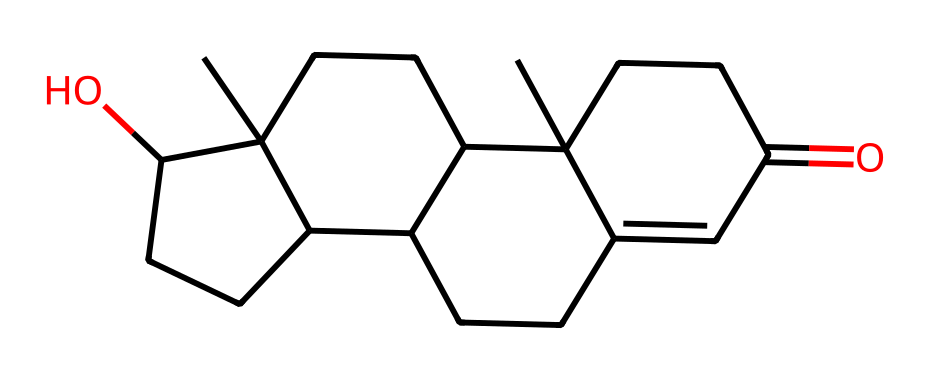What is the name of the hormone represented by this chemical structure? The SMILES representation corresponds to a molecule known for its role in hormone regulation and is specifically identified as testosterone.
Answer: testosterone How many carbon atoms are present in the structure? Analyzing the SMILES notation, each 'C' corresponds to a carbon atom, totaling up to 19 carbon atoms in the structure of testosterone.
Answer: 19 What is the functional group present in the structure? The structure includes an alcohol group (–OH) indicated by the 'O' connected to a carbon atom, which classifies it as a steroid with a hydroxyl functional group.
Answer: hydroxyl What type of molecule is testosterone classified as? Testosterone is classified as a steroid hormone due to its multi-ring structure and presence of functional groups typical of steroid compounds.
Answer: steroid How many rings are present in the molecular structure? The structure reveals four interconnected carbon rings, a characteristic feature of steroid hormones like testosterone.
Answer: 4 What influences might testosterone have on music preferences? Testosterone is linked with aggressive behavior and preference for genres like rock; its levels can influence listening habits, suggesting a potential correlation.
Answer: aggression and genre preferences 